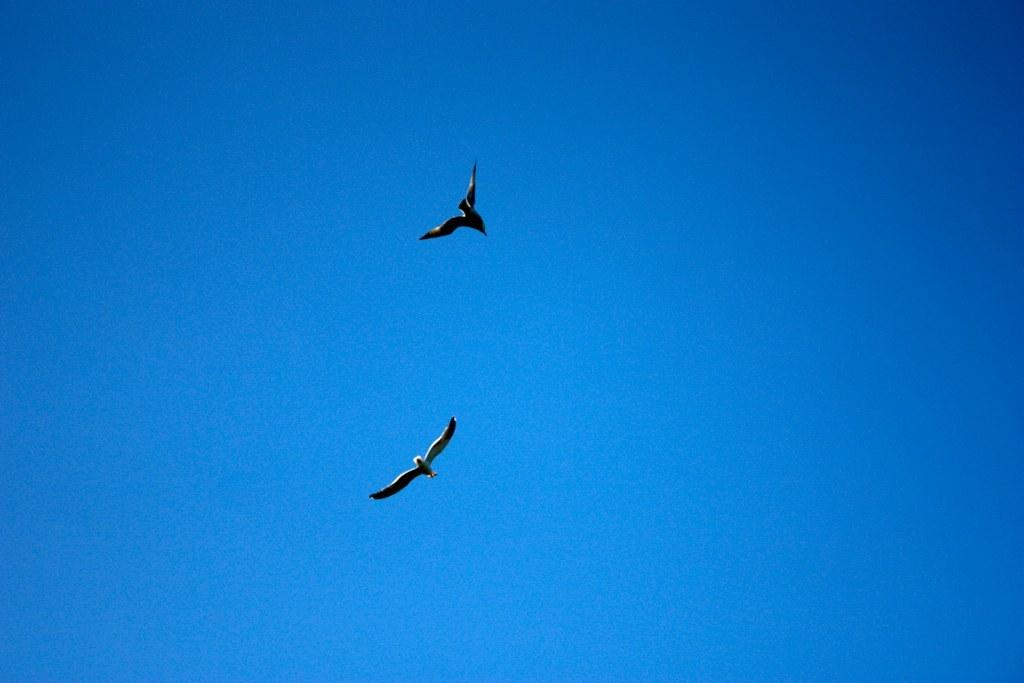How many birds are present in the image? There are two birds in the image. What colors can be seen on the birds? The birds are white and black in color. What are the birds doing in the image? The birds are flying in the air. What can be seen in the background of the image? The sky is visible in the background of the image. What type of shirt is the bird wearing in the image? Birds do not wear shirts, so this detail cannot be found in the image. 